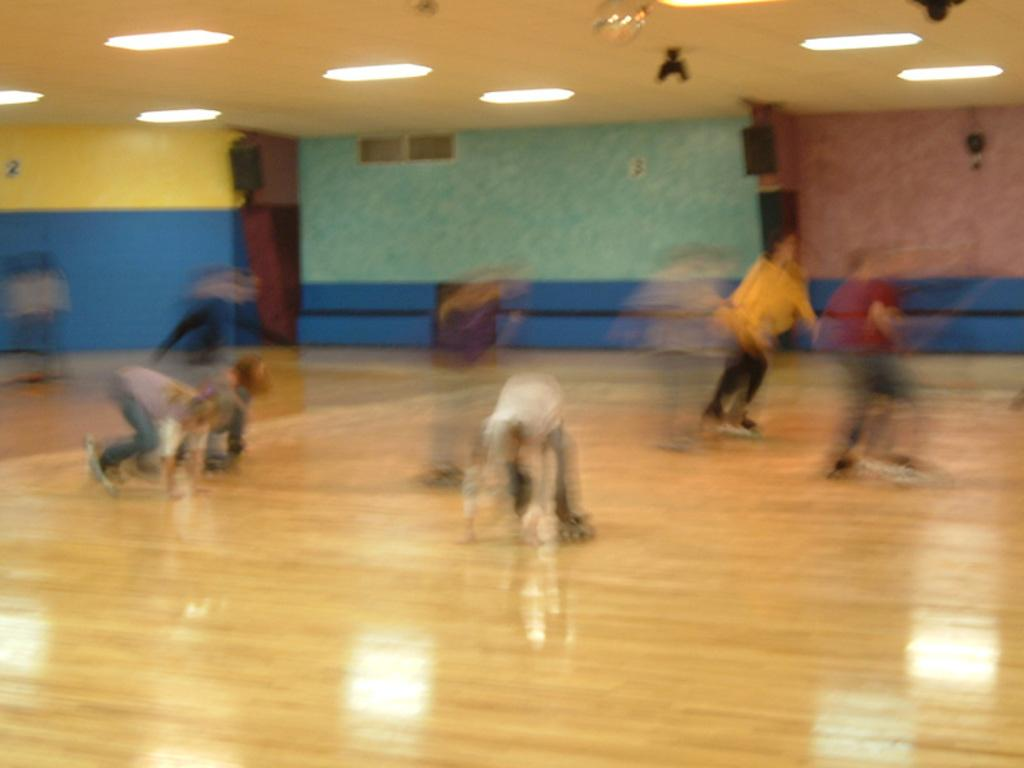Who or what can be seen in the image? There are people in the image. What are the people doing in the image? The people are skating on the floor. Can you describe any additional features in the image? There are lights present on the roof. What type of tail can be seen on the people skating in the image? There are no tails present on the people skating in the image. 